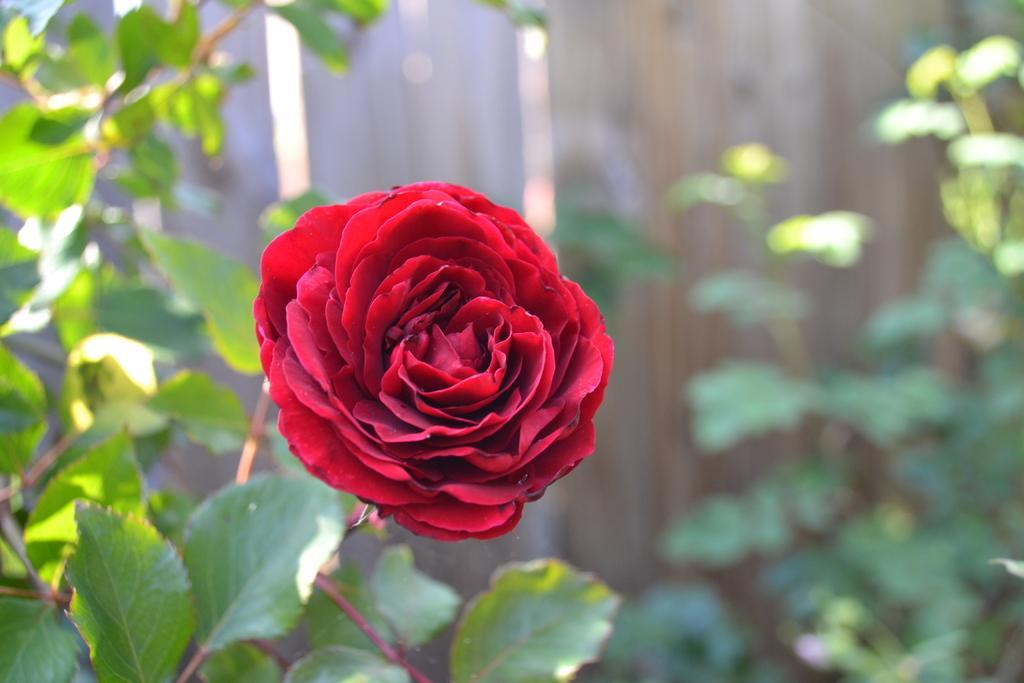In one or two sentences, can you explain what this image depicts? Here we can see a flower and plants. There is a blur background. 